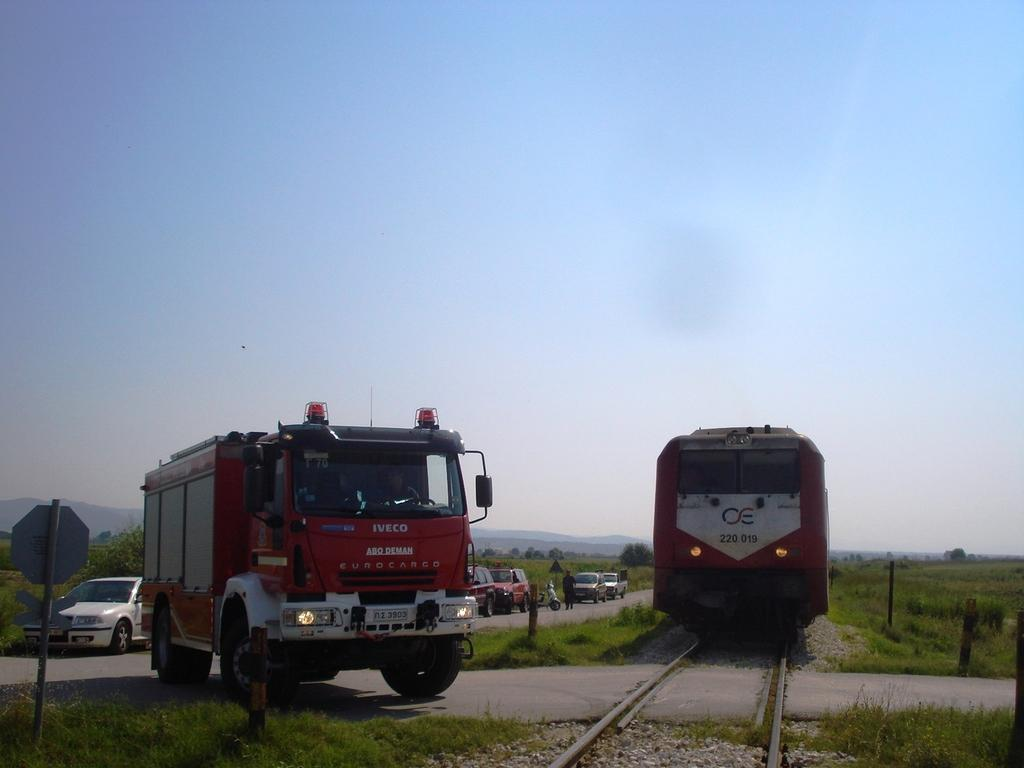What type of vehicle is on the track in the image? There is a locomotive on the track in the image. What other types of vehicles can be seen in the image? Motor vehicles are visible on the road in the image. What are some objects that provide information or directions in the image? Sign boards are present in the image. What type of landscape can be seen in the image? Agricultural fields and hills are visible in the image. What is the condition of the sky in the image? The sky is visible in the image. Are there any people present in the image? Yes, there are persons standing on the road in the image. What color of paint is being used to decorate the transport in the image? There is no mention of paint or decoration in the image; it features a locomotive on the track and motor vehicles on the road. What suggestion is being made by the persons standing on the road in the image? There is no indication of a suggestion being made by the persons in the image; they are simply standing on the road. 